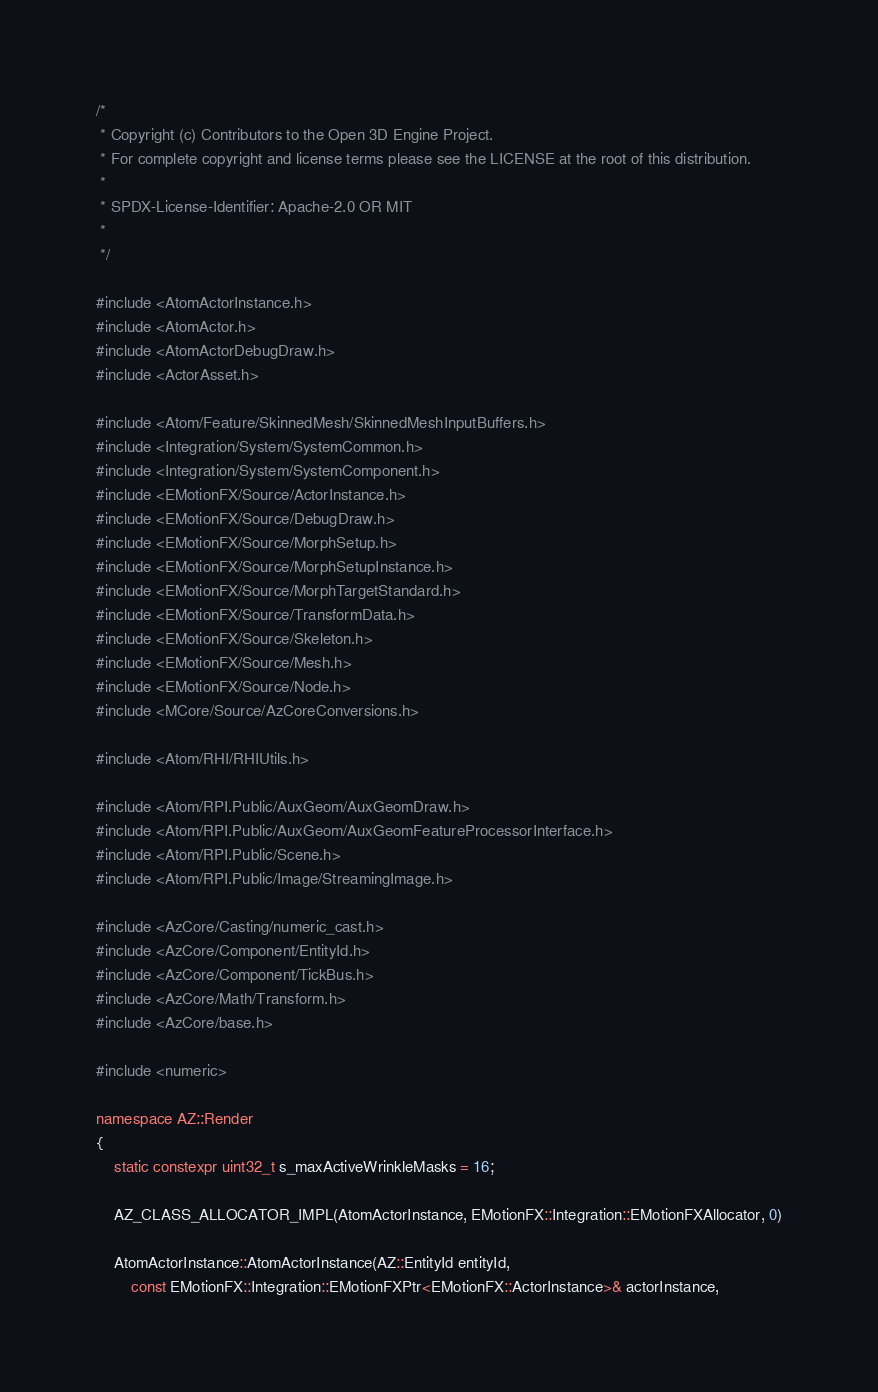Convert code to text. <code><loc_0><loc_0><loc_500><loc_500><_C++_>/*
 * Copyright (c) Contributors to the Open 3D Engine Project.
 * For complete copyright and license terms please see the LICENSE at the root of this distribution.
 *
 * SPDX-License-Identifier: Apache-2.0 OR MIT
 *
 */

#include <AtomActorInstance.h>
#include <AtomActor.h>
#include <AtomActorDebugDraw.h>
#include <ActorAsset.h>

#include <Atom/Feature/SkinnedMesh/SkinnedMeshInputBuffers.h>
#include <Integration/System/SystemCommon.h>
#include <Integration/System/SystemComponent.h>
#include <EMotionFX/Source/ActorInstance.h>
#include <EMotionFX/Source/DebugDraw.h>
#include <EMotionFX/Source/MorphSetup.h>
#include <EMotionFX/Source/MorphSetupInstance.h>
#include <EMotionFX/Source/MorphTargetStandard.h>
#include <EMotionFX/Source/TransformData.h>
#include <EMotionFX/Source/Skeleton.h>
#include <EMotionFX/Source/Mesh.h>
#include <EMotionFX/Source/Node.h>
#include <MCore/Source/AzCoreConversions.h>

#include <Atom/RHI/RHIUtils.h>

#include <Atom/RPI.Public/AuxGeom/AuxGeomDraw.h>
#include <Atom/RPI.Public/AuxGeom/AuxGeomFeatureProcessorInterface.h>
#include <Atom/RPI.Public/Scene.h>
#include <Atom/RPI.Public/Image/StreamingImage.h>

#include <AzCore/Casting/numeric_cast.h>
#include <AzCore/Component/EntityId.h>
#include <AzCore/Component/TickBus.h>
#include <AzCore/Math/Transform.h>
#include <AzCore/base.h>

#include <numeric>

namespace AZ::Render
{
    static constexpr uint32_t s_maxActiveWrinkleMasks = 16;

    AZ_CLASS_ALLOCATOR_IMPL(AtomActorInstance, EMotionFX::Integration::EMotionFXAllocator, 0)

    AtomActorInstance::AtomActorInstance(AZ::EntityId entityId,
        const EMotionFX::Integration::EMotionFXPtr<EMotionFX::ActorInstance>& actorInstance,</code> 